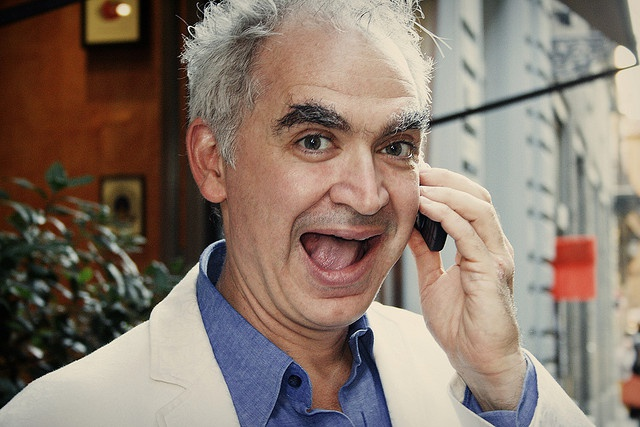Describe the objects in this image and their specific colors. I can see people in black, gray, tan, lightgray, and beige tones and cell phone in black and gray tones in this image. 